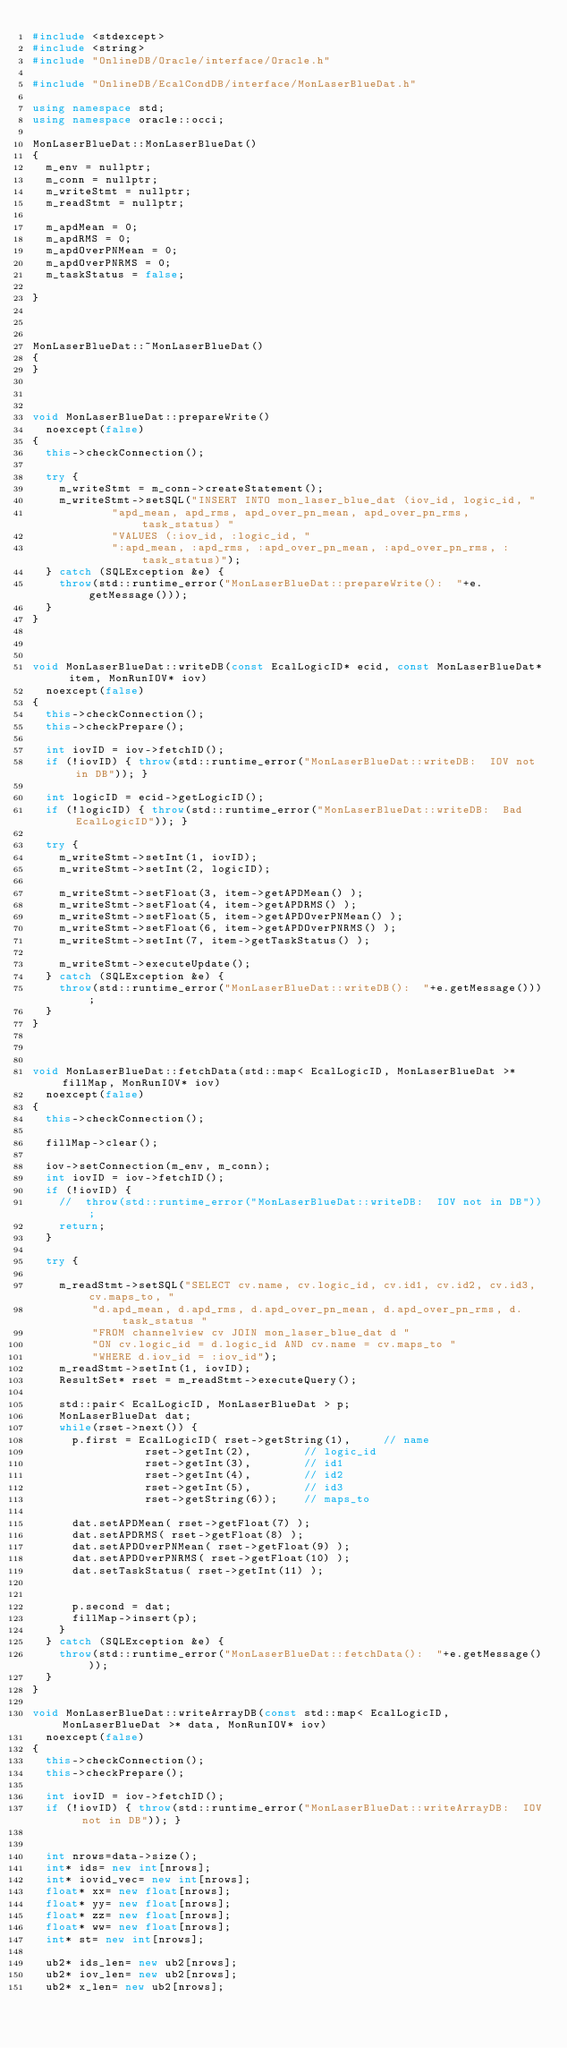Convert code to text. <code><loc_0><loc_0><loc_500><loc_500><_C++_>#include <stdexcept>
#include <string>
#include "OnlineDB/Oracle/interface/Oracle.h"

#include "OnlineDB/EcalCondDB/interface/MonLaserBlueDat.h"

using namespace std;
using namespace oracle::occi;

MonLaserBlueDat::MonLaserBlueDat()
{
  m_env = nullptr;
  m_conn = nullptr;
  m_writeStmt = nullptr;
  m_readStmt = nullptr;

  m_apdMean = 0;
  m_apdRMS = 0;
  m_apdOverPNMean = 0;
  m_apdOverPNRMS = 0;
  m_taskStatus = false;
  
}



MonLaserBlueDat::~MonLaserBlueDat()
{
}



void MonLaserBlueDat::prepareWrite()
  noexcept(false)
{
  this->checkConnection();

  try {
    m_writeStmt = m_conn->createStatement();
    m_writeStmt->setSQL("INSERT INTO mon_laser_blue_dat (iov_id, logic_id, "
			"apd_mean, apd_rms, apd_over_pn_mean, apd_over_pn_rms, task_status) "
			"VALUES (:iov_id, :logic_id, "
			":apd_mean, :apd_rms, :apd_over_pn_mean, :apd_over_pn_rms, :task_status)");
  } catch (SQLException &e) {
    throw(std::runtime_error("MonLaserBlueDat::prepareWrite():  "+e.getMessage()));
  }
}



void MonLaserBlueDat::writeDB(const EcalLogicID* ecid, const MonLaserBlueDat* item, MonRunIOV* iov)
  noexcept(false)
{
  this->checkConnection();
  this->checkPrepare();

  int iovID = iov->fetchID();
  if (!iovID) { throw(std::runtime_error("MonLaserBlueDat::writeDB:  IOV not in DB")); }

  int logicID = ecid->getLogicID();
  if (!logicID) { throw(std::runtime_error("MonLaserBlueDat::writeDB:  Bad EcalLogicID")); }
  
  try {
    m_writeStmt->setInt(1, iovID);
    m_writeStmt->setInt(2, logicID);

    m_writeStmt->setFloat(3, item->getAPDMean() );
    m_writeStmt->setFloat(4, item->getAPDRMS() );
    m_writeStmt->setFloat(5, item->getAPDOverPNMean() );
    m_writeStmt->setFloat(6, item->getAPDOverPNRMS() );
    m_writeStmt->setInt(7, item->getTaskStatus() );

    m_writeStmt->executeUpdate();
  } catch (SQLException &e) {
    throw(std::runtime_error("MonLaserBlueDat::writeDB():  "+e.getMessage()));
  }
}



void MonLaserBlueDat::fetchData(std::map< EcalLogicID, MonLaserBlueDat >* fillMap, MonRunIOV* iov)
  noexcept(false)
{
  this->checkConnection();

  fillMap->clear();

  iov->setConnection(m_env, m_conn);
  int iovID = iov->fetchID();
  if (!iovID) { 
    //  throw(std::runtime_error("MonLaserBlueDat::writeDB:  IOV not in DB")); 
    return;
  }

  try {
    
    m_readStmt->setSQL("SELECT cv.name, cv.logic_id, cv.id1, cv.id2, cv.id3, cv.maps_to, "
		 "d.apd_mean, d.apd_rms, d.apd_over_pn_mean, d.apd_over_pn_rms, d.task_status "
		 "FROM channelview cv JOIN mon_laser_blue_dat d "
		 "ON cv.logic_id = d.logic_id AND cv.name = cv.maps_to "
		 "WHERE d.iov_id = :iov_id");
    m_readStmt->setInt(1, iovID);
    ResultSet* rset = m_readStmt->executeQuery();
    
    std::pair< EcalLogicID, MonLaserBlueDat > p;
    MonLaserBlueDat dat;
    while(rset->next()) {
      p.first = EcalLogicID( rset->getString(1),     // name
			     rset->getInt(2),        // logic_id
			     rset->getInt(3),        // id1
			     rset->getInt(4),        // id2
			     rset->getInt(5),        // id3
			     rset->getString(6));    // maps_to

      dat.setAPDMean( rset->getFloat(7) );
      dat.setAPDRMS( rset->getFloat(8) );
      dat.setAPDOverPNMean( rset->getFloat(9) );
      dat.setAPDOverPNRMS( rset->getFloat(10) );
      dat.setTaskStatus( rset->getInt(11) );
			

      p.second = dat;
      fillMap->insert(p);
    }
  } catch (SQLException &e) {
    throw(std::runtime_error("MonLaserBlueDat::fetchData():  "+e.getMessage()));
  }
}

void MonLaserBlueDat::writeArrayDB(const std::map< EcalLogicID, MonLaserBlueDat >* data, MonRunIOV* iov)
  noexcept(false)
{
  this->checkConnection();
  this->checkPrepare();

  int iovID = iov->fetchID();
  if (!iovID) { throw(std::runtime_error("MonLaserBlueDat::writeArrayDB:  IOV not in DB")); }


  int nrows=data->size(); 
  int* ids= new int[nrows];
  int* iovid_vec= new int[nrows];
  float* xx= new float[nrows];
  float* yy= new float[nrows];
  float* zz= new float[nrows];
  float* ww= new float[nrows];
  int* st= new int[nrows];

  ub2* ids_len= new ub2[nrows];
  ub2* iov_len= new ub2[nrows];
  ub2* x_len= new ub2[nrows];</code> 